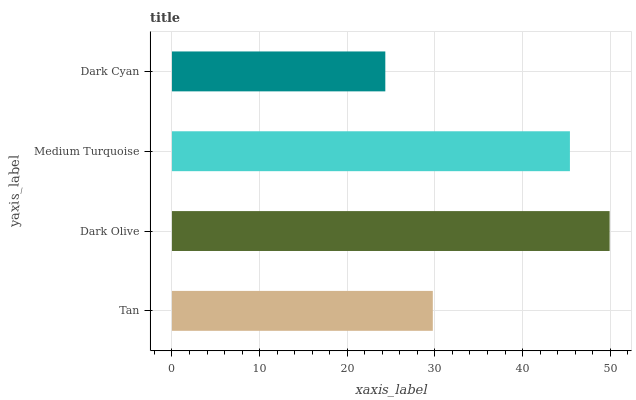Is Dark Cyan the minimum?
Answer yes or no. Yes. Is Dark Olive the maximum?
Answer yes or no. Yes. Is Medium Turquoise the minimum?
Answer yes or no. No. Is Medium Turquoise the maximum?
Answer yes or no. No. Is Dark Olive greater than Medium Turquoise?
Answer yes or no. Yes. Is Medium Turquoise less than Dark Olive?
Answer yes or no. Yes. Is Medium Turquoise greater than Dark Olive?
Answer yes or no. No. Is Dark Olive less than Medium Turquoise?
Answer yes or no. No. Is Medium Turquoise the high median?
Answer yes or no. Yes. Is Tan the low median?
Answer yes or no. Yes. Is Dark Cyan the high median?
Answer yes or no. No. Is Dark Cyan the low median?
Answer yes or no. No. 